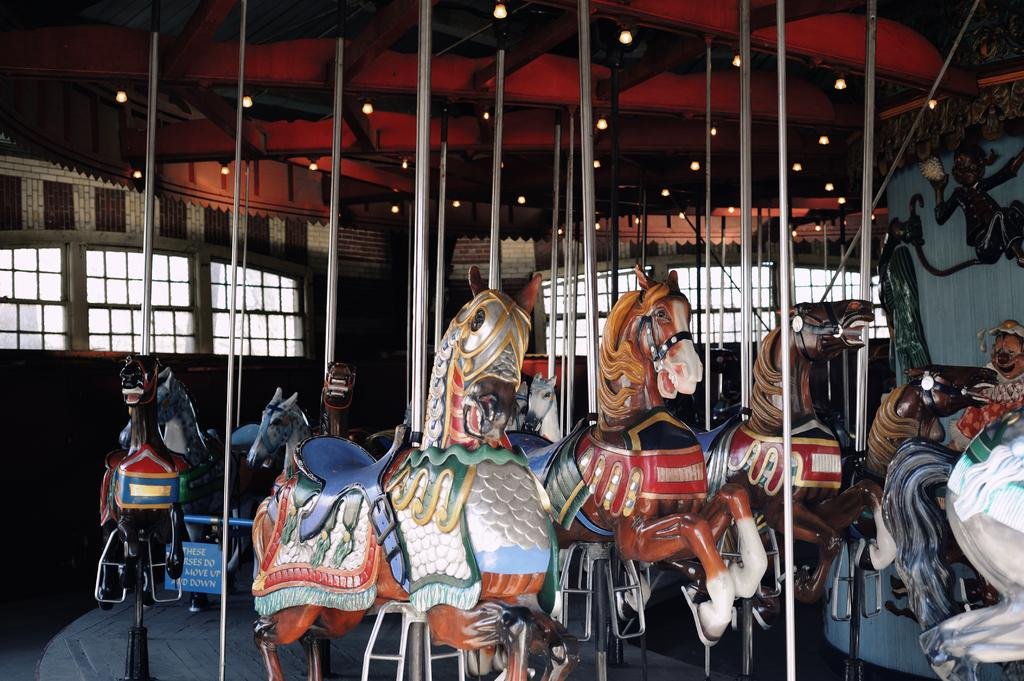What is the main subject in the image? There is a carousel in the image. What can be seen in the background of the image? There is a wall and windows visible in the background. What type of lighting is present in the image? There are lights at the top of the image. What type of meal is being served on the carousel in the image? There is no meal present in the image; it features a carousel with lights and a background wall with windows. 